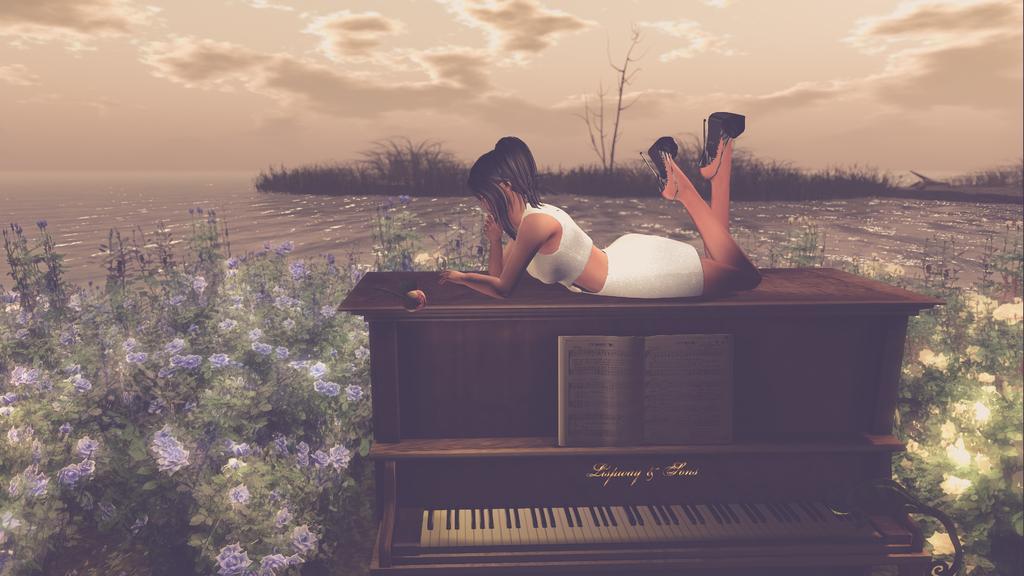Could you give a brief overview of what you see in this image? In this picture I can observe a woman lying on the piano. It is a graphical image. In the middle of the picture I can observe river. In the bottom of the picture I can observe flowers. I can observe clouds in the sky. 